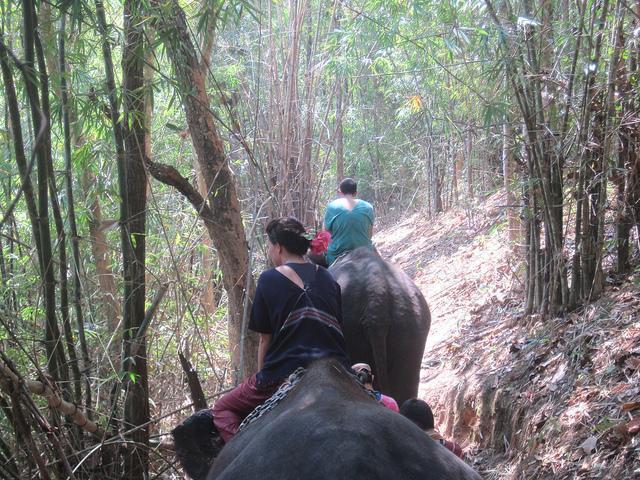How many animals?
Give a very brief answer. 2. How many elephants can you see?
Give a very brief answer. 2. How many people are in the photo?
Give a very brief answer. 2. How many dogs are there?
Give a very brief answer. 0. 